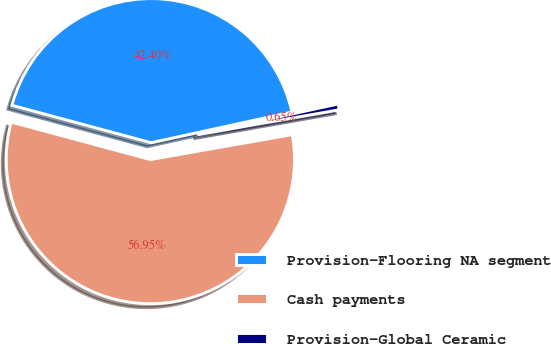Convert chart. <chart><loc_0><loc_0><loc_500><loc_500><pie_chart><fcel>Provision-Flooring NA segment<fcel>Cash payments<fcel>Provision-Global Ceramic<nl><fcel>42.4%<fcel>56.95%<fcel>0.65%<nl></chart> 